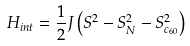Convert formula to latex. <formula><loc_0><loc_0><loc_500><loc_500>H _ { i n t } = \frac { 1 } { 2 } J \left ( S ^ { 2 } - S _ { N } ^ { 2 } - S _ { c _ { 6 0 } } ^ { 2 } \right )</formula> 